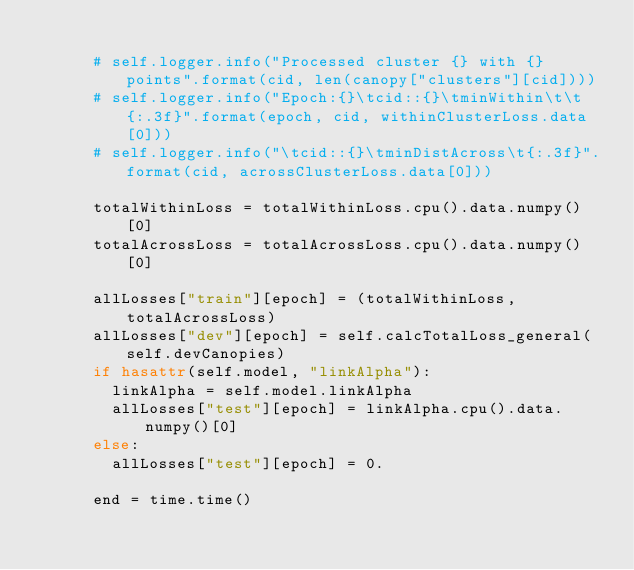<code> <loc_0><loc_0><loc_500><loc_500><_Python_>			
			# self.logger.info("Processed cluster {} with {} points".format(cid, len(canopy["clusters"][cid])))
			# self.logger.info("Epoch:{}\tcid::{}\tminWithin\t\t{:.3f}".format(epoch, cid, withinClusterLoss.data[0]))
			# self.logger.info("\tcid::{}\tminDistAcross\t{:.3f}".format(cid, acrossClusterLoss.data[0]))
			
			totalWithinLoss = totalWithinLoss.cpu().data.numpy()[0]
			totalAcrossLoss = totalAcrossLoss.cpu().data.numpy()[0]
			
			allLosses["train"][epoch] = (totalWithinLoss, totalAcrossLoss)
			allLosses["dev"][epoch] = self.calcTotalLoss_general(self.devCanopies)
			if hasattr(self.model, "linkAlpha"):
				linkAlpha = self.model.linkAlpha
				allLosses["test"][epoch] = linkAlpha.cpu().data.numpy()[0]
			else:
				allLosses["test"][epoch] = 0.
			
			end = time.time()</code> 